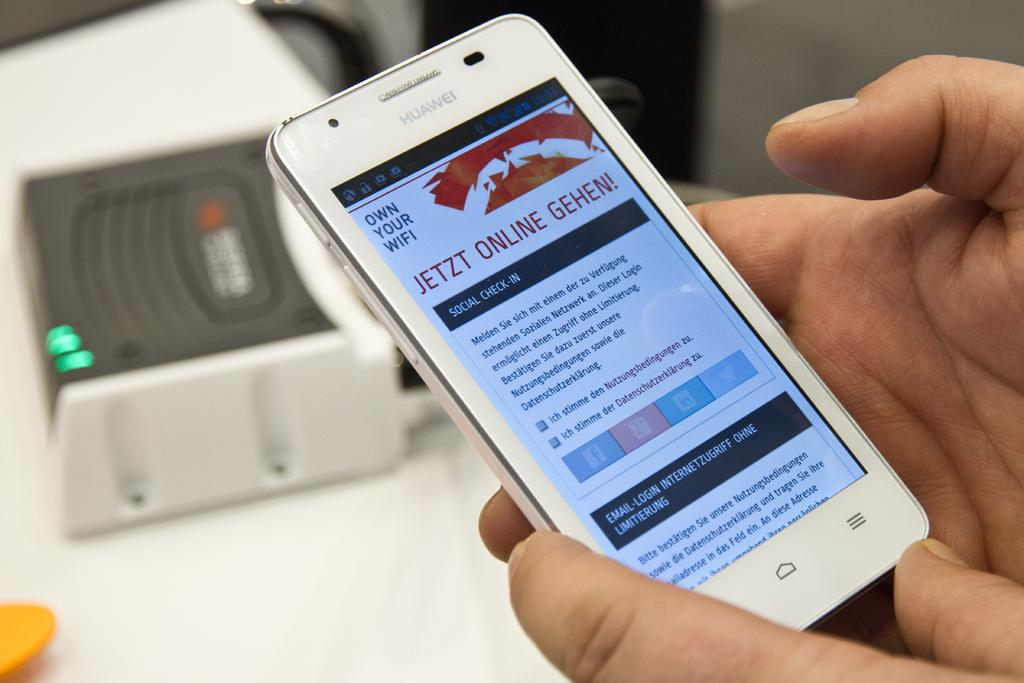<image>
Share a concise interpretation of the image provided. A phone that is on with JETZT ONLINE GEHEN on the screen 